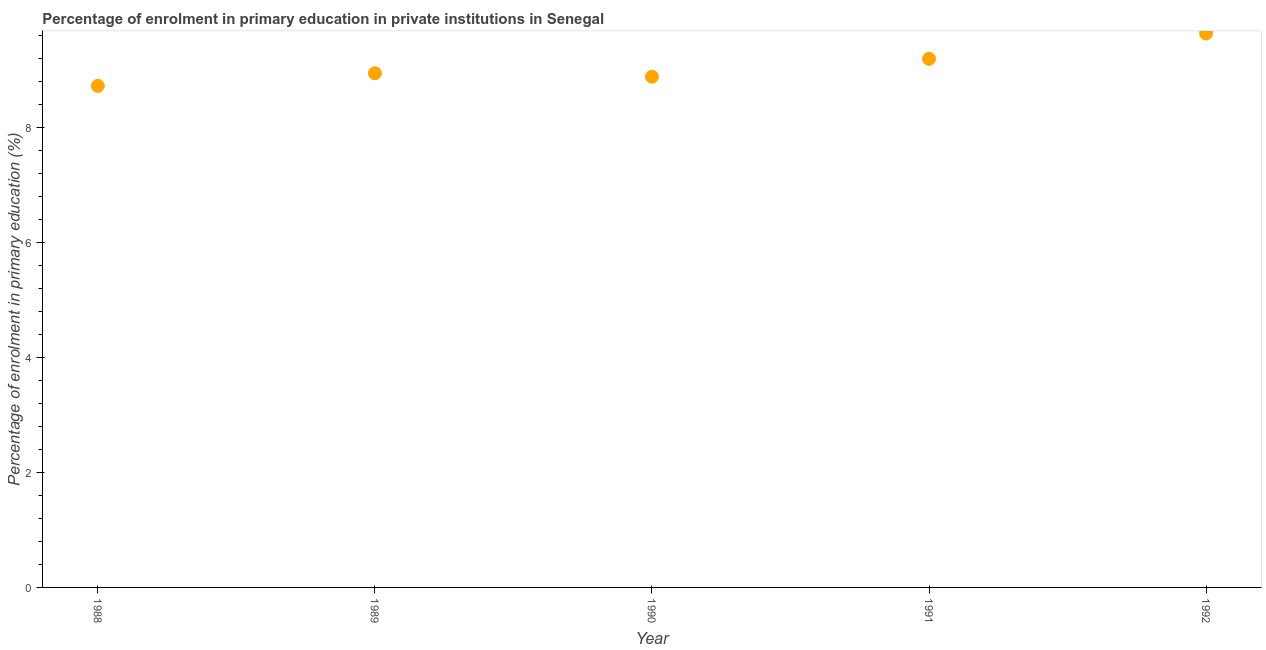What is the enrolment percentage in primary education in 1989?
Your response must be concise. 8.95. Across all years, what is the maximum enrolment percentage in primary education?
Keep it short and to the point. 9.64. Across all years, what is the minimum enrolment percentage in primary education?
Provide a short and direct response. 8.73. In which year was the enrolment percentage in primary education minimum?
Make the answer very short. 1988. What is the sum of the enrolment percentage in primary education?
Offer a terse response. 45.4. What is the difference between the enrolment percentage in primary education in 1989 and 1990?
Provide a succinct answer. 0.06. What is the average enrolment percentage in primary education per year?
Offer a very short reply. 9.08. What is the median enrolment percentage in primary education?
Provide a succinct answer. 8.95. Do a majority of the years between 1991 and 1990 (inclusive) have enrolment percentage in primary education greater than 7.2 %?
Your response must be concise. No. What is the ratio of the enrolment percentage in primary education in 1989 to that in 1992?
Provide a succinct answer. 0.93. What is the difference between the highest and the second highest enrolment percentage in primary education?
Offer a very short reply. 0.44. What is the difference between the highest and the lowest enrolment percentage in primary education?
Your answer should be very brief. 0.91. Does the enrolment percentage in primary education monotonically increase over the years?
Make the answer very short. No. How many dotlines are there?
Provide a succinct answer. 1. Does the graph contain any zero values?
Give a very brief answer. No. Does the graph contain grids?
Your response must be concise. No. What is the title of the graph?
Your response must be concise. Percentage of enrolment in primary education in private institutions in Senegal. What is the label or title of the Y-axis?
Your answer should be very brief. Percentage of enrolment in primary education (%). What is the Percentage of enrolment in primary education (%) in 1988?
Make the answer very short. 8.73. What is the Percentage of enrolment in primary education (%) in 1989?
Provide a short and direct response. 8.95. What is the Percentage of enrolment in primary education (%) in 1990?
Offer a terse response. 8.89. What is the Percentage of enrolment in primary education (%) in 1991?
Keep it short and to the point. 9.2. What is the Percentage of enrolment in primary education (%) in 1992?
Give a very brief answer. 9.64. What is the difference between the Percentage of enrolment in primary education (%) in 1988 and 1989?
Provide a succinct answer. -0.22. What is the difference between the Percentage of enrolment in primary education (%) in 1988 and 1990?
Make the answer very short. -0.16. What is the difference between the Percentage of enrolment in primary education (%) in 1988 and 1991?
Ensure brevity in your answer.  -0.47. What is the difference between the Percentage of enrolment in primary education (%) in 1988 and 1992?
Your answer should be very brief. -0.91. What is the difference between the Percentage of enrolment in primary education (%) in 1989 and 1990?
Offer a terse response. 0.06. What is the difference between the Percentage of enrolment in primary education (%) in 1989 and 1991?
Offer a terse response. -0.25. What is the difference between the Percentage of enrolment in primary education (%) in 1989 and 1992?
Offer a terse response. -0.69. What is the difference between the Percentage of enrolment in primary education (%) in 1990 and 1991?
Keep it short and to the point. -0.31. What is the difference between the Percentage of enrolment in primary education (%) in 1990 and 1992?
Keep it short and to the point. -0.75. What is the difference between the Percentage of enrolment in primary education (%) in 1991 and 1992?
Offer a terse response. -0.44. What is the ratio of the Percentage of enrolment in primary education (%) in 1988 to that in 1989?
Give a very brief answer. 0.97. What is the ratio of the Percentage of enrolment in primary education (%) in 1988 to that in 1991?
Your answer should be compact. 0.95. What is the ratio of the Percentage of enrolment in primary education (%) in 1988 to that in 1992?
Your answer should be very brief. 0.91. What is the ratio of the Percentage of enrolment in primary education (%) in 1989 to that in 1990?
Provide a succinct answer. 1.01. What is the ratio of the Percentage of enrolment in primary education (%) in 1989 to that in 1991?
Make the answer very short. 0.97. What is the ratio of the Percentage of enrolment in primary education (%) in 1989 to that in 1992?
Offer a very short reply. 0.93. What is the ratio of the Percentage of enrolment in primary education (%) in 1990 to that in 1992?
Offer a terse response. 0.92. What is the ratio of the Percentage of enrolment in primary education (%) in 1991 to that in 1992?
Give a very brief answer. 0.95. 